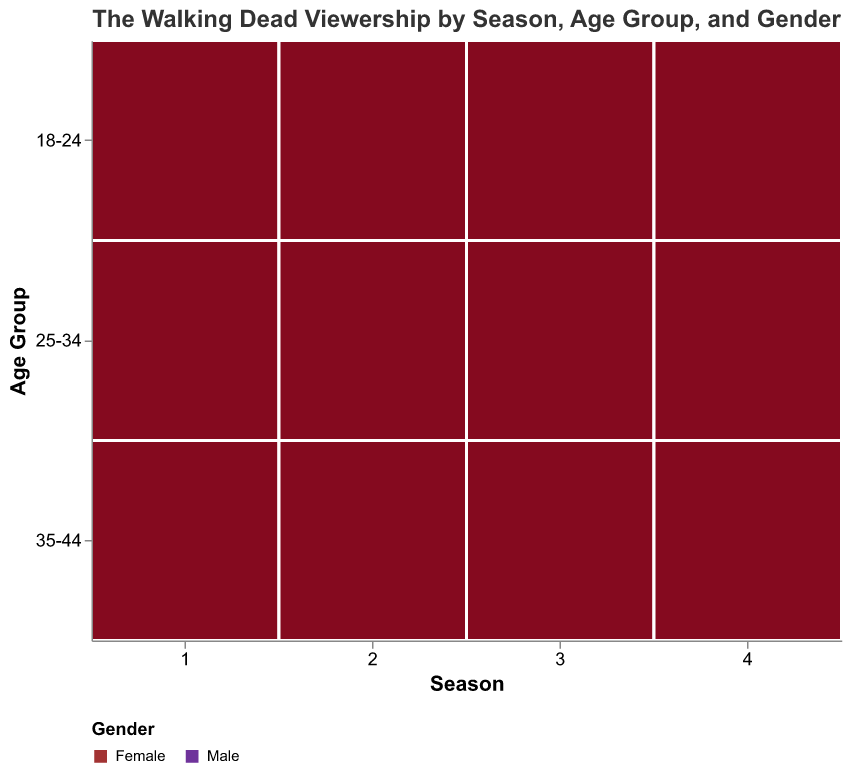What's the viewership of males aged 18-24 in Season 2? Find the rectangle corresponding to males aged 18-24 in Season 2 and note the viewership value.
Answer: 4.1 Which gender had higher viewership in the age group 25-34 during Season 3? Compare the viewership numbers for males and females in the 25-34 age group during Season 3.
Answer: Male What is the overall trend in viewership across seasons? Observe the size and color saturation of the rectangles across seasons to note the changing viewership.
Answer: Increasing What age group had the highest viewership in Season 4? Identify the age group with the largest size/area of rectangles in Season 4.
Answer: 25-34 How does the female viewership in the 35-44 age group change from Season 1 to Season 4? Track the size of rectangles and the corresponding values for females in the 35-44 age group across all seasons.
Answer: It increases What is the difference in viewership between males and females aged 25-34 in Season 1? Subtract the viewership value of females from that of males aged 25-34 in Season 1.
Answer: 0.6 Which age group had the lowest viewership in Season 1? Identify the age group with the smallest size/area of rectangles in Season 1.
Answer: 18-24 What age group shows the most consistent viewership across all seasons? Compare the variability in size/area of rectangles for each age group across all seasons.
Answer: 35-44 Who had the highest viewership in all seasons: males aged 18-24 or males aged 35-44? Compare the size/area of rectangles of males aged 18-24 and males aged 35-44 across all seasons.
Answer: Males aged 25-34 Is there any season where female viewership exceeded male viewership for any age group? Check each age group across all seasons to see if the size/area of the female rectangles exceeds that of the male rectangles.
Answer: No 